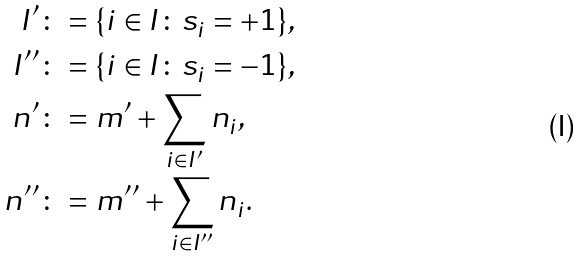<formula> <loc_0><loc_0><loc_500><loc_500>I ^ { \prime } & \colon = \{ i \in I \colon s _ { i } = + 1 \} , \\ I ^ { \prime \prime } & \colon = \{ i \in I \colon s _ { i } = - 1 \} , \\ n ^ { \prime } & \colon = m ^ { \prime } + \sum _ { i \in I ^ { \prime } } n _ { i } , \\ n ^ { \prime \prime } & \colon = m ^ { \prime \prime } + \sum _ { i \in I ^ { \prime \prime } } n _ { i } .</formula> 